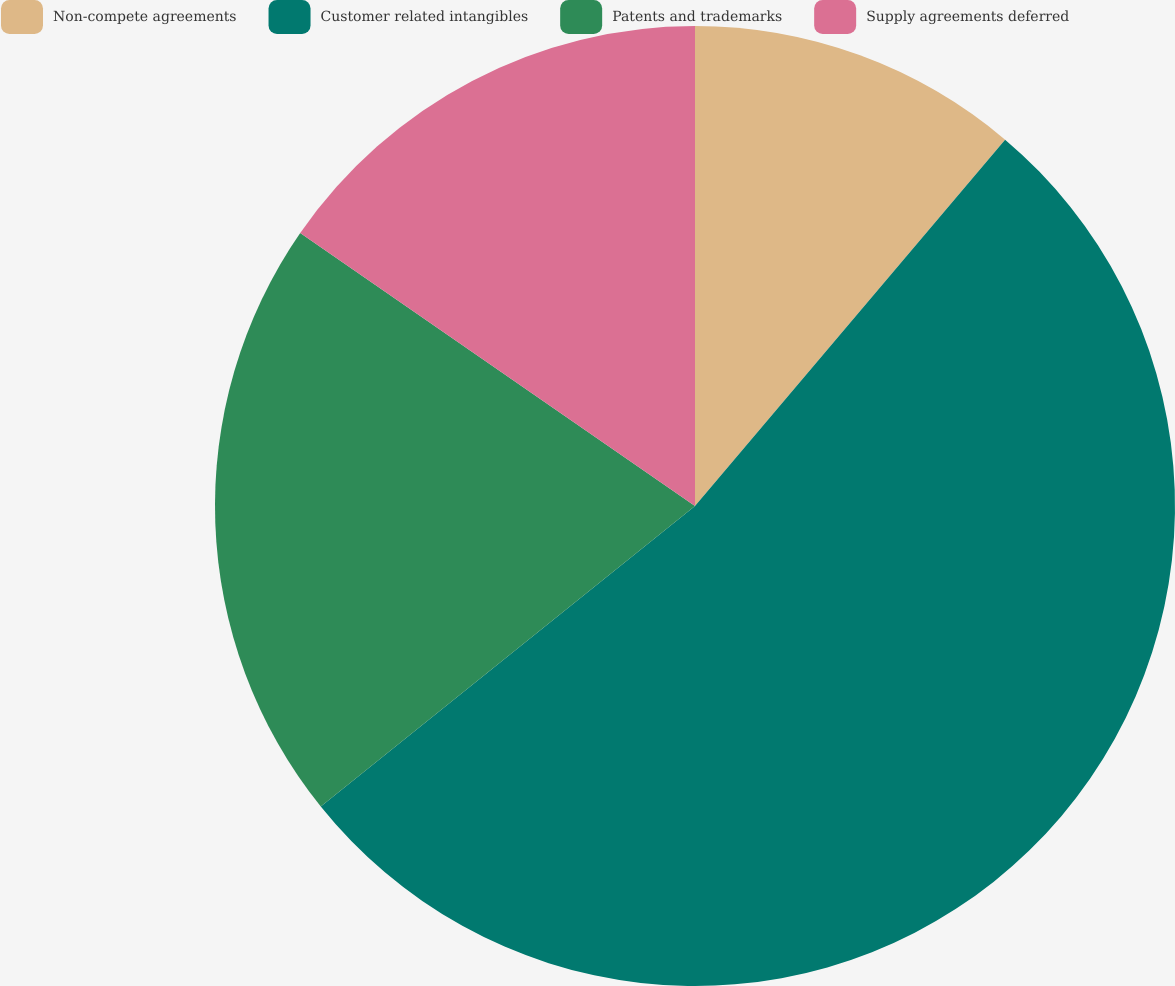<chart> <loc_0><loc_0><loc_500><loc_500><pie_chart><fcel>Non-compete agreements<fcel>Customer related intangibles<fcel>Patents and trademarks<fcel>Supply agreements deferred<nl><fcel>11.18%<fcel>53.05%<fcel>20.4%<fcel>15.37%<nl></chart> 